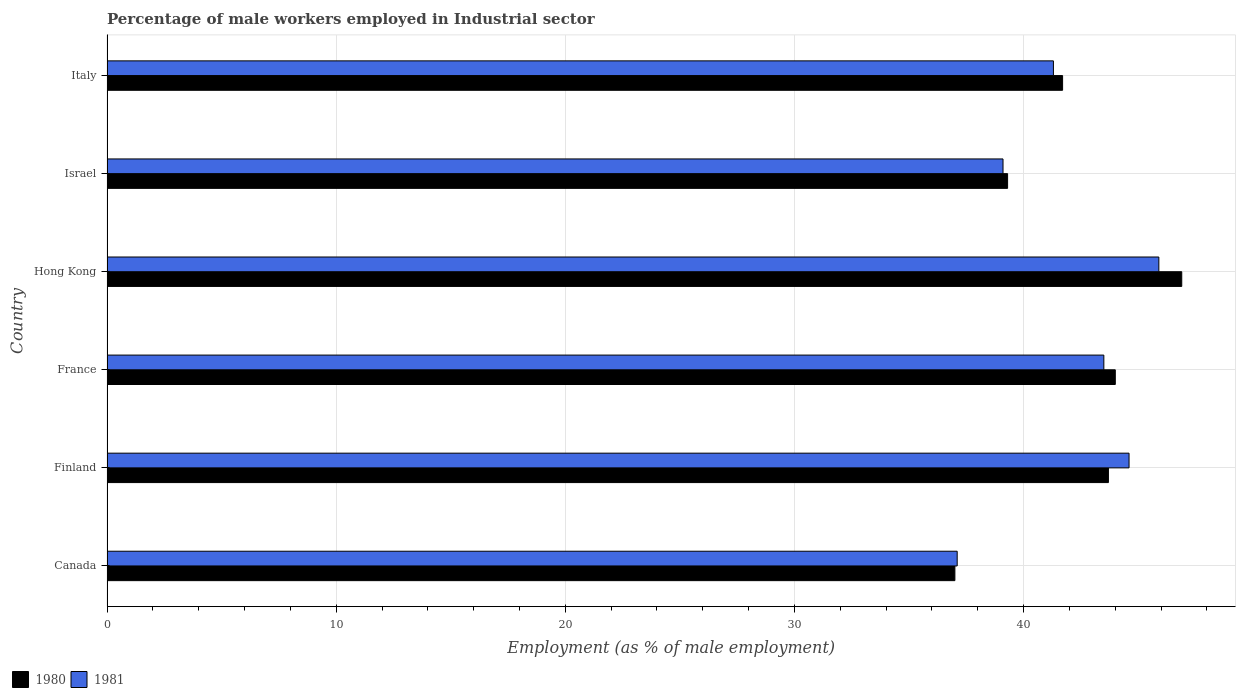How many different coloured bars are there?
Provide a short and direct response. 2. How many groups of bars are there?
Provide a short and direct response. 6. Are the number of bars on each tick of the Y-axis equal?
Offer a very short reply. Yes. How many bars are there on the 5th tick from the bottom?
Your response must be concise. 2. What is the label of the 2nd group of bars from the top?
Ensure brevity in your answer.  Israel. What is the percentage of male workers employed in Industrial sector in 1981 in Canada?
Your response must be concise. 37.1. Across all countries, what is the maximum percentage of male workers employed in Industrial sector in 1980?
Provide a succinct answer. 46.9. In which country was the percentage of male workers employed in Industrial sector in 1981 maximum?
Your response must be concise. Hong Kong. In which country was the percentage of male workers employed in Industrial sector in 1981 minimum?
Offer a very short reply. Canada. What is the total percentage of male workers employed in Industrial sector in 1980 in the graph?
Offer a terse response. 252.6. What is the difference between the percentage of male workers employed in Industrial sector in 1981 in Finland and that in Israel?
Provide a short and direct response. 5.5. What is the difference between the percentage of male workers employed in Industrial sector in 1980 in Finland and the percentage of male workers employed in Industrial sector in 1981 in France?
Offer a terse response. 0.2. What is the average percentage of male workers employed in Industrial sector in 1981 per country?
Make the answer very short. 41.92. What is the difference between the percentage of male workers employed in Industrial sector in 1980 and percentage of male workers employed in Industrial sector in 1981 in Finland?
Provide a succinct answer. -0.9. In how many countries, is the percentage of male workers employed in Industrial sector in 1981 greater than 16 %?
Make the answer very short. 6. What is the ratio of the percentage of male workers employed in Industrial sector in 1981 in Hong Kong to that in Israel?
Offer a very short reply. 1.17. Is the difference between the percentage of male workers employed in Industrial sector in 1980 in Canada and Italy greater than the difference between the percentage of male workers employed in Industrial sector in 1981 in Canada and Italy?
Give a very brief answer. No. What is the difference between the highest and the second highest percentage of male workers employed in Industrial sector in 1980?
Offer a very short reply. 2.9. What is the difference between the highest and the lowest percentage of male workers employed in Industrial sector in 1981?
Keep it short and to the point. 8.8. In how many countries, is the percentage of male workers employed in Industrial sector in 1981 greater than the average percentage of male workers employed in Industrial sector in 1981 taken over all countries?
Provide a short and direct response. 3. What does the 1st bar from the bottom in Italy represents?
Your answer should be very brief. 1980. Are all the bars in the graph horizontal?
Provide a short and direct response. Yes. How many countries are there in the graph?
Keep it short and to the point. 6. What is the difference between two consecutive major ticks on the X-axis?
Give a very brief answer. 10. Are the values on the major ticks of X-axis written in scientific E-notation?
Provide a succinct answer. No. Does the graph contain grids?
Ensure brevity in your answer.  Yes. How many legend labels are there?
Provide a short and direct response. 2. What is the title of the graph?
Your answer should be very brief. Percentage of male workers employed in Industrial sector. What is the label or title of the X-axis?
Your answer should be very brief. Employment (as % of male employment). What is the Employment (as % of male employment) of 1981 in Canada?
Make the answer very short. 37.1. What is the Employment (as % of male employment) in 1980 in Finland?
Keep it short and to the point. 43.7. What is the Employment (as % of male employment) of 1981 in Finland?
Your answer should be compact. 44.6. What is the Employment (as % of male employment) of 1980 in France?
Make the answer very short. 44. What is the Employment (as % of male employment) of 1981 in France?
Keep it short and to the point. 43.5. What is the Employment (as % of male employment) in 1980 in Hong Kong?
Provide a short and direct response. 46.9. What is the Employment (as % of male employment) of 1981 in Hong Kong?
Give a very brief answer. 45.9. What is the Employment (as % of male employment) in 1980 in Israel?
Your answer should be compact. 39.3. What is the Employment (as % of male employment) of 1981 in Israel?
Your answer should be very brief. 39.1. What is the Employment (as % of male employment) in 1980 in Italy?
Ensure brevity in your answer.  41.7. What is the Employment (as % of male employment) of 1981 in Italy?
Provide a succinct answer. 41.3. Across all countries, what is the maximum Employment (as % of male employment) of 1980?
Offer a terse response. 46.9. Across all countries, what is the maximum Employment (as % of male employment) in 1981?
Provide a succinct answer. 45.9. Across all countries, what is the minimum Employment (as % of male employment) in 1980?
Offer a very short reply. 37. Across all countries, what is the minimum Employment (as % of male employment) of 1981?
Keep it short and to the point. 37.1. What is the total Employment (as % of male employment) in 1980 in the graph?
Give a very brief answer. 252.6. What is the total Employment (as % of male employment) in 1981 in the graph?
Provide a succinct answer. 251.5. What is the difference between the Employment (as % of male employment) in 1981 in Canada and that in Finland?
Offer a terse response. -7.5. What is the difference between the Employment (as % of male employment) in 1981 in Canada and that in France?
Provide a succinct answer. -6.4. What is the difference between the Employment (as % of male employment) of 1981 in Canada and that in Israel?
Provide a short and direct response. -2. What is the difference between the Employment (as % of male employment) in 1981 in Canada and that in Italy?
Keep it short and to the point. -4.2. What is the difference between the Employment (as % of male employment) in 1980 in Finland and that in Israel?
Your answer should be compact. 4.4. What is the difference between the Employment (as % of male employment) of 1980 in Finland and that in Italy?
Ensure brevity in your answer.  2. What is the difference between the Employment (as % of male employment) of 1981 in Finland and that in Italy?
Your answer should be very brief. 3.3. What is the difference between the Employment (as % of male employment) of 1980 in France and that in Israel?
Ensure brevity in your answer.  4.7. What is the difference between the Employment (as % of male employment) of 1981 in France and that in Israel?
Your response must be concise. 4.4. What is the difference between the Employment (as % of male employment) in 1980 in France and that in Italy?
Offer a very short reply. 2.3. What is the difference between the Employment (as % of male employment) of 1981 in France and that in Italy?
Make the answer very short. 2.2. What is the difference between the Employment (as % of male employment) in 1980 in Hong Kong and that in Israel?
Offer a very short reply. 7.6. What is the difference between the Employment (as % of male employment) in 1981 in Hong Kong and that in Israel?
Give a very brief answer. 6.8. What is the difference between the Employment (as % of male employment) in 1980 in Hong Kong and that in Italy?
Keep it short and to the point. 5.2. What is the difference between the Employment (as % of male employment) of 1980 in Israel and that in Italy?
Provide a short and direct response. -2.4. What is the difference between the Employment (as % of male employment) of 1981 in Israel and that in Italy?
Your response must be concise. -2.2. What is the difference between the Employment (as % of male employment) in 1980 in Canada and the Employment (as % of male employment) in 1981 in Finland?
Make the answer very short. -7.6. What is the difference between the Employment (as % of male employment) in 1980 in Canada and the Employment (as % of male employment) in 1981 in Israel?
Your response must be concise. -2.1. What is the difference between the Employment (as % of male employment) in 1980 in Canada and the Employment (as % of male employment) in 1981 in Italy?
Make the answer very short. -4.3. What is the difference between the Employment (as % of male employment) of 1980 in Finland and the Employment (as % of male employment) of 1981 in Hong Kong?
Your answer should be compact. -2.2. What is the difference between the Employment (as % of male employment) in 1980 in Finland and the Employment (as % of male employment) in 1981 in Israel?
Ensure brevity in your answer.  4.6. What is the difference between the Employment (as % of male employment) of 1980 in France and the Employment (as % of male employment) of 1981 in Israel?
Provide a succinct answer. 4.9. What is the difference between the Employment (as % of male employment) in 1980 in Hong Kong and the Employment (as % of male employment) in 1981 in Israel?
Offer a terse response. 7.8. What is the difference between the Employment (as % of male employment) of 1980 in Israel and the Employment (as % of male employment) of 1981 in Italy?
Offer a terse response. -2. What is the average Employment (as % of male employment) of 1980 per country?
Offer a terse response. 42.1. What is the average Employment (as % of male employment) of 1981 per country?
Your answer should be very brief. 41.92. What is the difference between the Employment (as % of male employment) in 1980 and Employment (as % of male employment) in 1981 in France?
Provide a succinct answer. 0.5. What is the ratio of the Employment (as % of male employment) of 1980 in Canada to that in Finland?
Offer a terse response. 0.85. What is the ratio of the Employment (as % of male employment) in 1981 in Canada to that in Finland?
Provide a succinct answer. 0.83. What is the ratio of the Employment (as % of male employment) of 1980 in Canada to that in France?
Make the answer very short. 0.84. What is the ratio of the Employment (as % of male employment) of 1981 in Canada to that in France?
Offer a very short reply. 0.85. What is the ratio of the Employment (as % of male employment) in 1980 in Canada to that in Hong Kong?
Your answer should be very brief. 0.79. What is the ratio of the Employment (as % of male employment) in 1981 in Canada to that in Hong Kong?
Provide a short and direct response. 0.81. What is the ratio of the Employment (as % of male employment) in 1980 in Canada to that in Israel?
Keep it short and to the point. 0.94. What is the ratio of the Employment (as % of male employment) of 1981 in Canada to that in Israel?
Your answer should be compact. 0.95. What is the ratio of the Employment (as % of male employment) in 1980 in Canada to that in Italy?
Provide a succinct answer. 0.89. What is the ratio of the Employment (as % of male employment) in 1981 in Canada to that in Italy?
Offer a very short reply. 0.9. What is the ratio of the Employment (as % of male employment) of 1980 in Finland to that in France?
Keep it short and to the point. 0.99. What is the ratio of the Employment (as % of male employment) in 1981 in Finland to that in France?
Ensure brevity in your answer.  1.03. What is the ratio of the Employment (as % of male employment) of 1980 in Finland to that in Hong Kong?
Provide a short and direct response. 0.93. What is the ratio of the Employment (as % of male employment) in 1981 in Finland to that in Hong Kong?
Your response must be concise. 0.97. What is the ratio of the Employment (as % of male employment) of 1980 in Finland to that in Israel?
Your answer should be very brief. 1.11. What is the ratio of the Employment (as % of male employment) in 1981 in Finland to that in Israel?
Your response must be concise. 1.14. What is the ratio of the Employment (as % of male employment) in 1980 in Finland to that in Italy?
Ensure brevity in your answer.  1.05. What is the ratio of the Employment (as % of male employment) in 1981 in Finland to that in Italy?
Your response must be concise. 1.08. What is the ratio of the Employment (as % of male employment) of 1980 in France to that in Hong Kong?
Keep it short and to the point. 0.94. What is the ratio of the Employment (as % of male employment) in 1981 in France to that in Hong Kong?
Give a very brief answer. 0.95. What is the ratio of the Employment (as % of male employment) in 1980 in France to that in Israel?
Give a very brief answer. 1.12. What is the ratio of the Employment (as % of male employment) in 1981 in France to that in Israel?
Provide a short and direct response. 1.11. What is the ratio of the Employment (as % of male employment) in 1980 in France to that in Italy?
Your response must be concise. 1.06. What is the ratio of the Employment (as % of male employment) in 1981 in France to that in Italy?
Provide a short and direct response. 1.05. What is the ratio of the Employment (as % of male employment) of 1980 in Hong Kong to that in Israel?
Your answer should be very brief. 1.19. What is the ratio of the Employment (as % of male employment) in 1981 in Hong Kong to that in Israel?
Offer a terse response. 1.17. What is the ratio of the Employment (as % of male employment) in 1980 in Hong Kong to that in Italy?
Give a very brief answer. 1.12. What is the ratio of the Employment (as % of male employment) of 1981 in Hong Kong to that in Italy?
Keep it short and to the point. 1.11. What is the ratio of the Employment (as % of male employment) of 1980 in Israel to that in Italy?
Offer a terse response. 0.94. What is the ratio of the Employment (as % of male employment) in 1981 in Israel to that in Italy?
Keep it short and to the point. 0.95. What is the difference between the highest and the second highest Employment (as % of male employment) in 1980?
Offer a terse response. 2.9. What is the difference between the highest and the second highest Employment (as % of male employment) of 1981?
Provide a short and direct response. 1.3. What is the difference between the highest and the lowest Employment (as % of male employment) of 1981?
Keep it short and to the point. 8.8. 